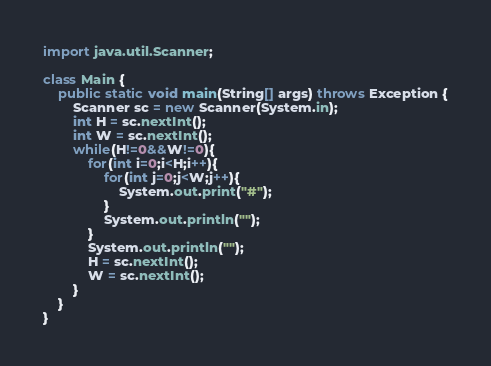<code> <loc_0><loc_0><loc_500><loc_500><_Java_>import java.util.Scanner;

class Main {
	public static void main(String[] args) throws Exception {
		Scanner sc = new Scanner(System.in);
		int H = sc.nextInt();
		int W = sc.nextInt();
		while(H!=0&&W!=0){
			for(int i=0;i<H;i++){
				for(int j=0;j<W;j++){
					System.out.print("#");
				}
				System.out.println("");
			}
			System.out.println("");
			H = sc.nextInt();
			W = sc.nextInt();
		}
	}
}</code> 